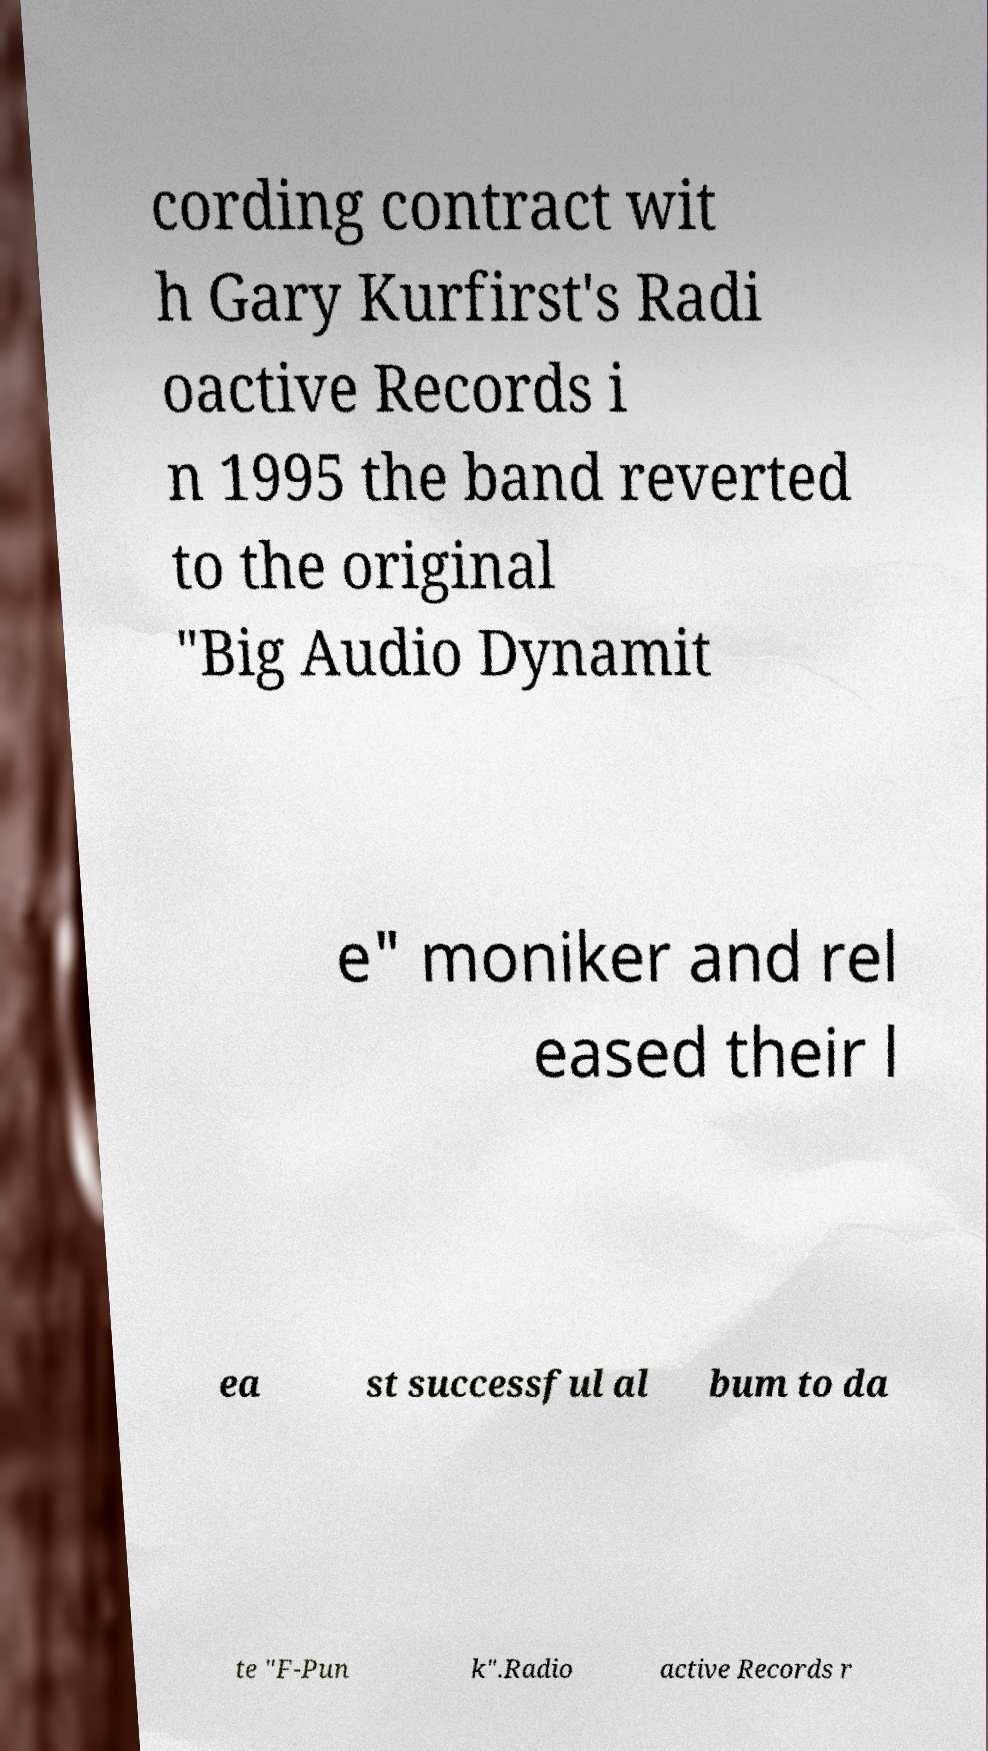Can you read and provide the text displayed in the image?This photo seems to have some interesting text. Can you extract and type it out for me? cording contract wit h Gary Kurfirst's Radi oactive Records i n 1995 the band reverted to the original "Big Audio Dynamit e" moniker and rel eased their l ea st successful al bum to da te "F-Pun k".Radio active Records r 